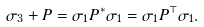<formula> <loc_0><loc_0><loc_500><loc_500>\sigma _ { 3 } + P = \sigma _ { 1 } P ^ { \ast } \sigma _ { 1 } = \sigma _ { 1 } P ^ { \top } \sigma _ { 1 } .</formula> 